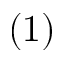<formula> <loc_0><loc_0><loc_500><loc_500>( 1 )</formula> 